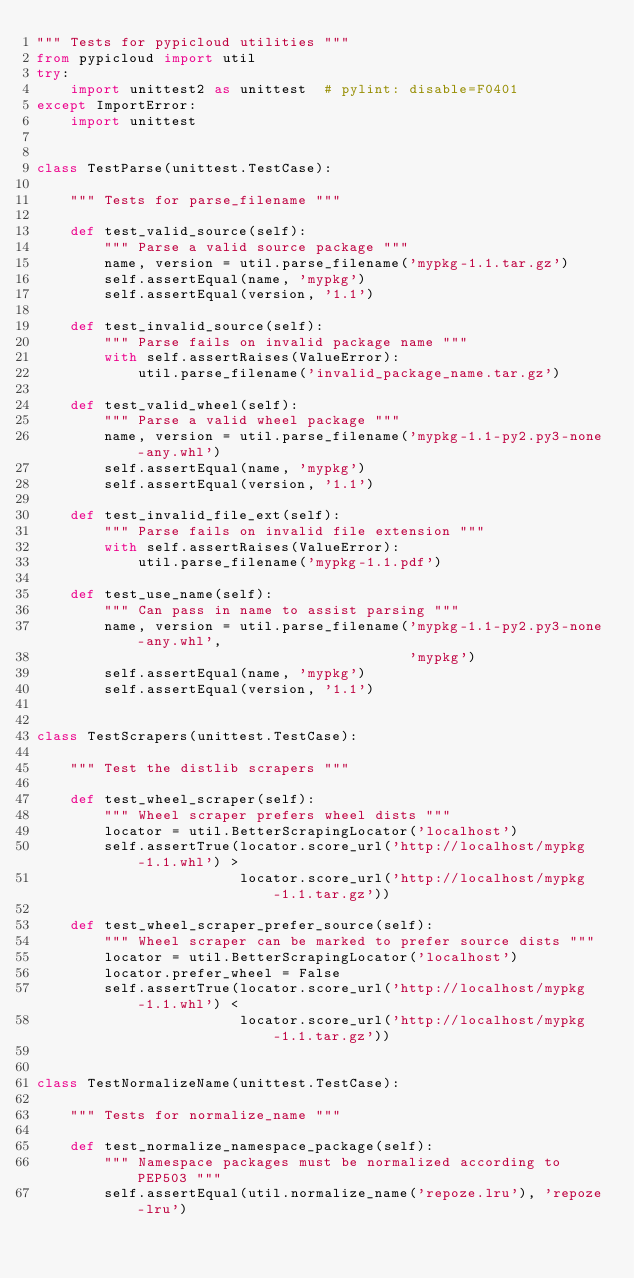Convert code to text. <code><loc_0><loc_0><loc_500><loc_500><_Python_>""" Tests for pypicloud utilities """
from pypicloud import util
try:
    import unittest2 as unittest  # pylint: disable=F0401
except ImportError:
    import unittest


class TestParse(unittest.TestCase):

    """ Tests for parse_filename """

    def test_valid_source(self):
        """ Parse a valid source package """
        name, version = util.parse_filename('mypkg-1.1.tar.gz')
        self.assertEqual(name, 'mypkg')
        self.assertEqual(version, '1.1')

    def test_invalid_source(self):
        """ Parse fails on invalid package name """
        with self.assertRaises(ValueError):
            util.parse_filename('invalid_package_name.tar.gz')

    def test_valid_wheel(self):
        """ Parse a valid wheel package """
        name, version = util.parse_filename('mypkg-1.1-py2.py3-none-any.whl')
        self.assertEqual(name, 'mypkg')
        self.assertEqual(version, '1.1')

    def test_invalid_file_ext(self):
        """ Parse fails on invalid file extension """
        with self.assertRaises(ValueError):
            util.parse_filename('mypkg-1.1.pdf')

    def test_use_name(self):
        """ Can pass in name to assist parsing """
        name, version = util.parse_filename('mypkg-1.1-py2.py3-none-any.whl',
                                            'mypkg')
        self.assertEqual(name, 'mypkg')
        self.assertEqual(version, '1.1')


class TestScrapers(unittest.TestCase):

    """ Test the distlib scrapers """

    def test_wheel_scraper(self):
        """ Wheel scraper prefers wheel dists """
        locator = util.BetterScrapingLocator('localhost')
        self.assertTrue(locator.score_url('http://localhost/mypkg-1.1.whl') >
                        locator.score_url('http://localhost/mypkg-1.1.tar.gz'))

    def test_wheel_scraper_prefer_source(self):
        """ Wheel scraper can be marked to prefer source dists """
        locator = util.BetterScrapingLocator('localhost')
        locator.prefer_wheel = False
        self.assertTrue(locator.score_url('http://localhost/mypkg-1.1.whl') <
                        locator.score_url('http://localhost/mypkg-1.1.tar.gz'))


class TestNormalizeName(unittest.TestCase):

    """ Tests for normalize_name """

    def test_normalize_namespace_package(self):
        """ Namespace packages must be normalized according to PEP503 """
        self.assertEqual(util.normalize_name('repoze.lru'), 'repoze-lru')
</code> 